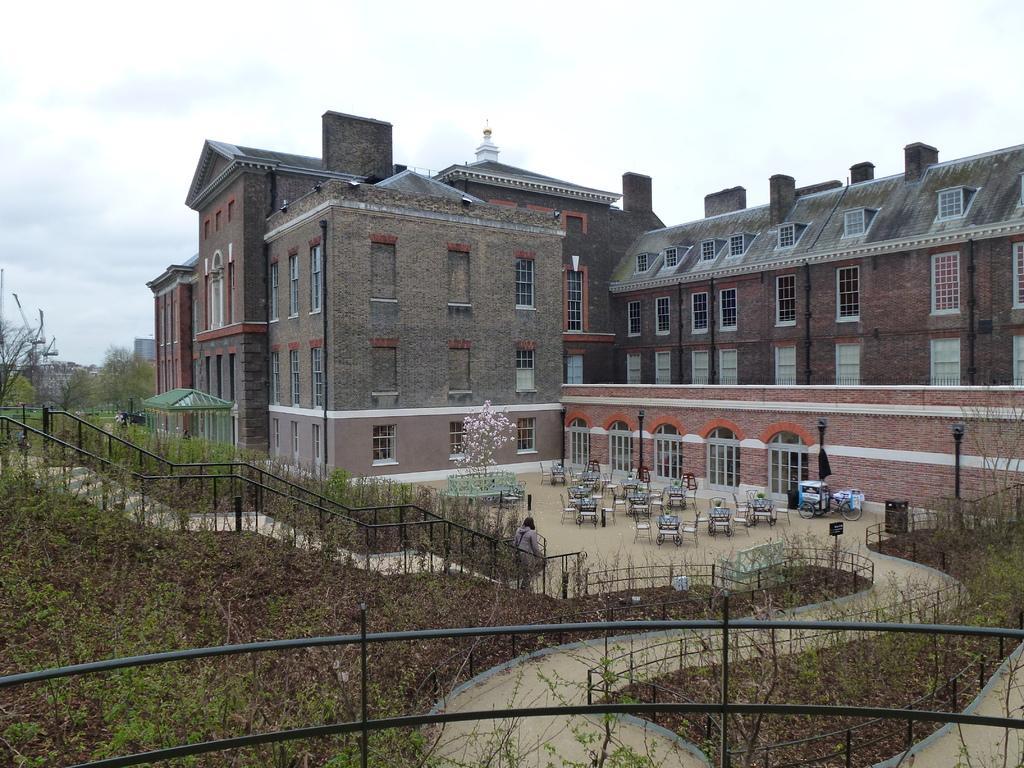Describe this image in one or two sentences. In the center of the image we can see building. At the bottom of the image we can see chairs, tables, plants, fencing and grass. In the background we can see sky and clouds. 